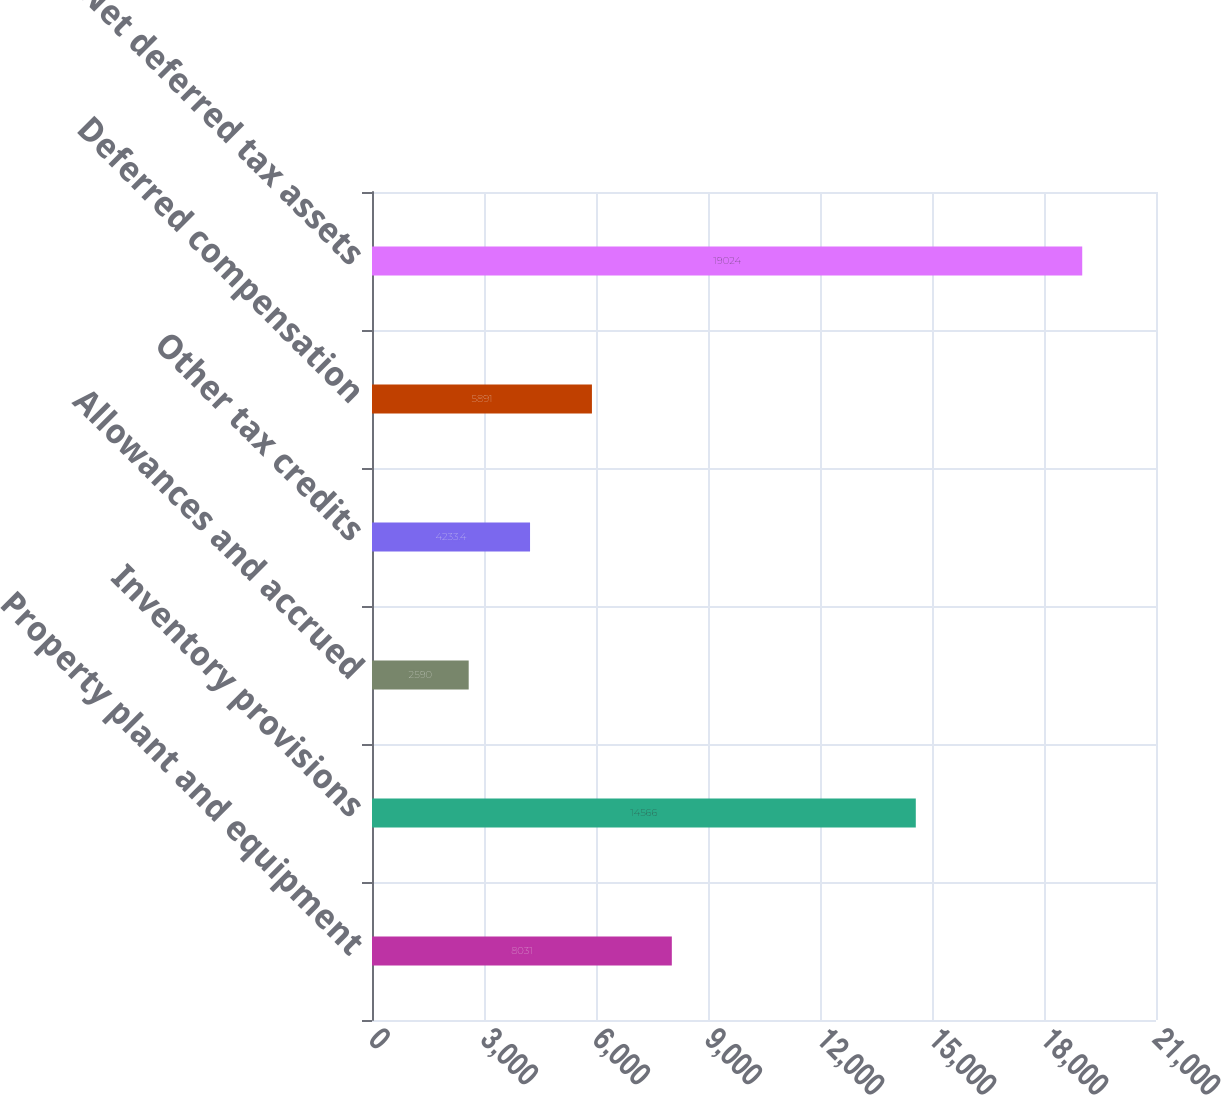Convert chart. <chart><loc_0><loc_0><loc_500><loc_500><bar_chart><fcel>Property plant and equipment<fcel>Inventory provisions<fcel>Allowances and accrued<fcel>Other tax credits<fcel>Deferred compensation<fcel>Net deferred tax assets<nl><fcel>8031<fcel>14566<fcel>2590<fcel>4233.4<fcel>5891<fcel>19024<nl></chart> 